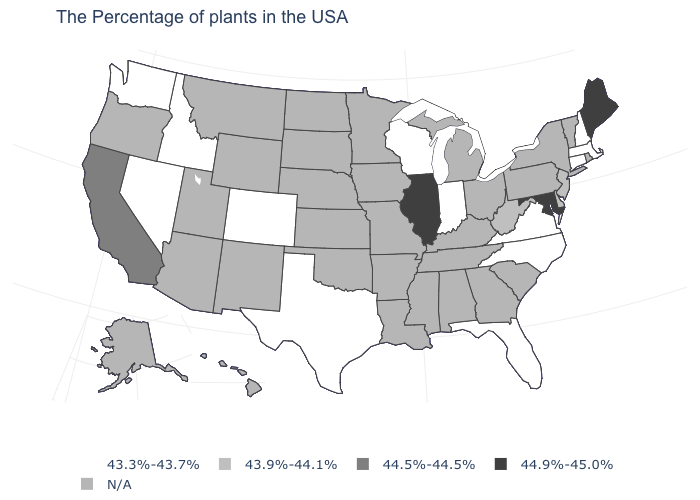Among the states that border Michigan , which have the lowest value?
Concise answer only. Indiana, Wisconsin. What is the value of New Hampshire?
Quick response, please. 43.3%-43.7%. What is the value of New Hampshire?
Write a very short answer. 43.3%-43.7%. Among the states that border Delaware , does Maryland have the lowest value?
Answer briefly. No. Which states have the highest value in the USA?
Concise answer only. Maine, Maryland, Illinois. What is the value of Illinois?
Write a very short answer. 44.9%-45.0%. What is the value of Connecticut?
Concise answer only. 43.3%-43.7%. Among the states that border Louisiana , which have the highest value?
Concise answer only. Texas. Is the legend a continuous bar?
Short answer required. No. Does Maine have the highest value in the Northeast?
Quick response, please. Yes. What is the lowest value in the MidWest?
Quick response, please. 43.3%-43.7%. Which states have the lowest value in the USA?
Short answer required. Massachusetts, New Hampshire, Connecticut, Virginia, North Carolina, Florida, Indiana, Wisconsin, Texas, Colorado, Idaho, Nevada, Washington. Name the states that have a value in the range 44.9%-45.0%?
Keep it brief. Maine, Maryland, Illinois. 